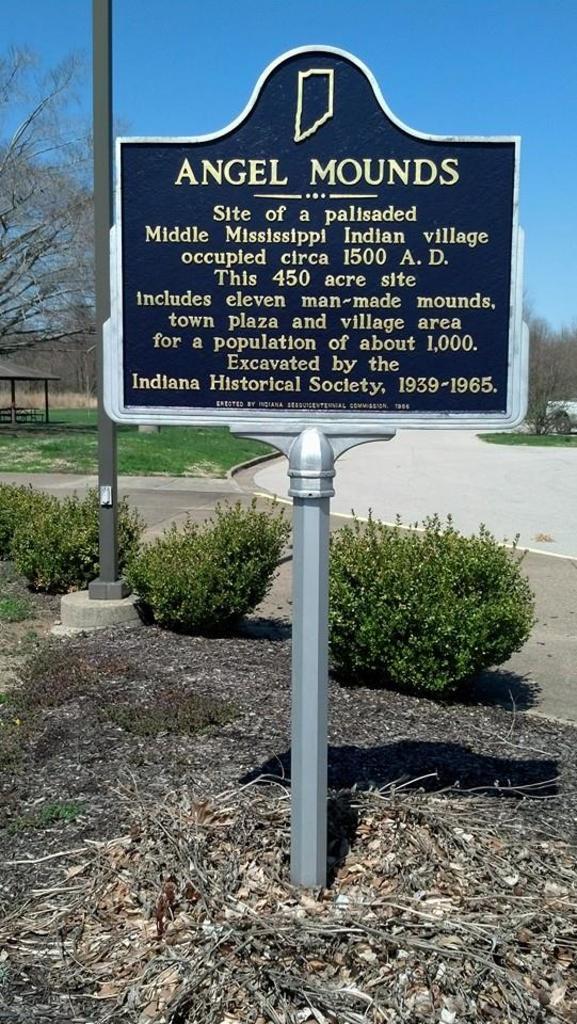Could you give a brief overview of what you see in this image? In the center of the image there is a board on the ground. In the background there are trees, pole, plants, road and sky. 